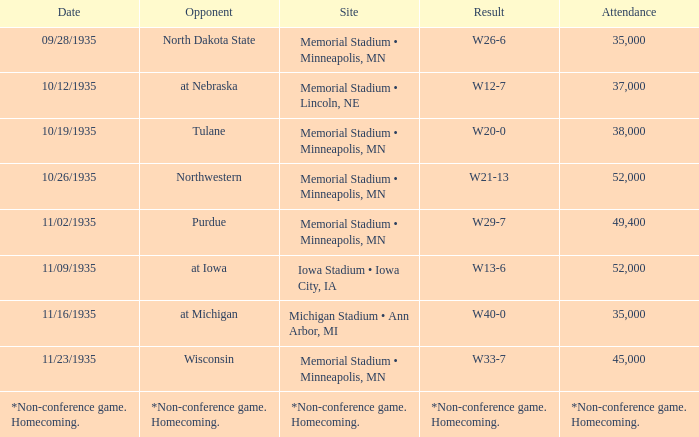On which date was the result w20-0? 10/19/1935. 